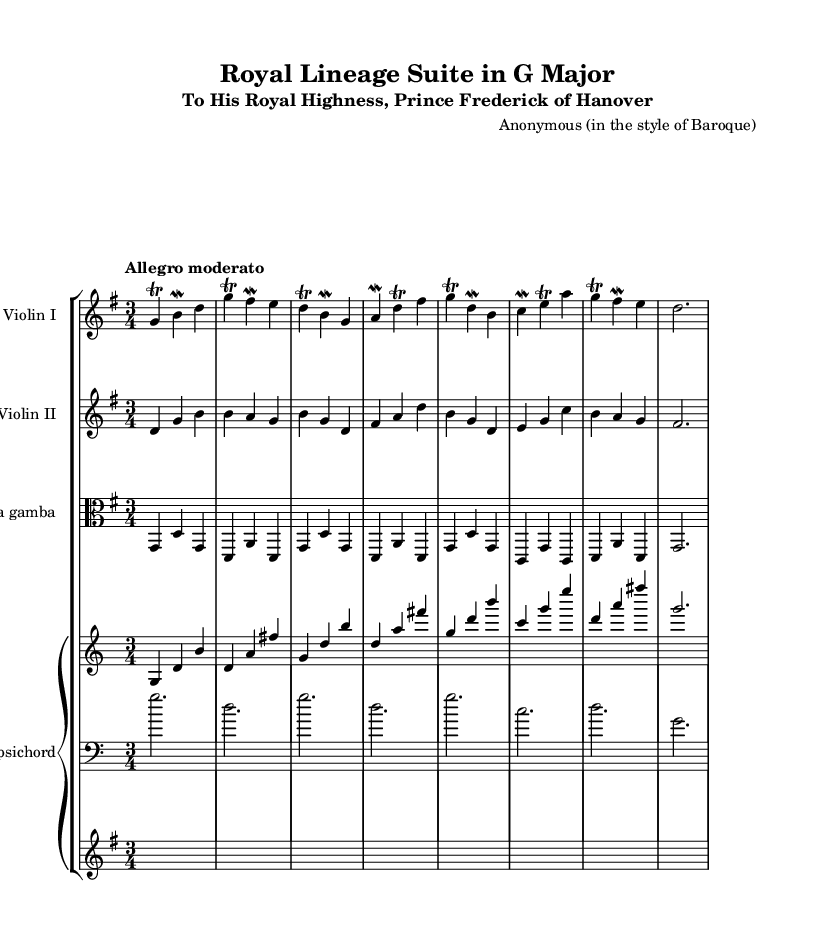What is the key signature of this music? The key signature shows one sharp, indicating it is in G major.
Answer: G major What is the time signature of the piece? The time signature is indicated at the beginning of the score, showing there are three beats per measure.
Answer: 3/4 What is the tempo marking of this piece? The tempo marking is found at the start of the score, describing the speed as moderately fast.
Answer: Allegro moderato How many different instrument parts are indicated in this score? By counting the listed instrument names in the score, we find there are four parts: Violin I, Violin II, Viola da gamba, and Harpsichord.
Answer: Four What is the name of the work's dedicatee? The dedicatee is mentioned in the subtitle of the score, revealing it is composed for Prince Frederick of Hanover.
Answer: Prince Frederick of Hanover Which instrumentation is unique to chamber music as represented here? The use of the harpsichord as a continuo instrument in chamber settings is typical of Baroque music, emphasizing the blend of strings and keyboard.
Answer: Harpsichord What musical ornamentation appears frequently in this score? The score employs trills and mordents as decorative features, common in Baroque music to embellish the melody.
Answer: Trills and mordents 